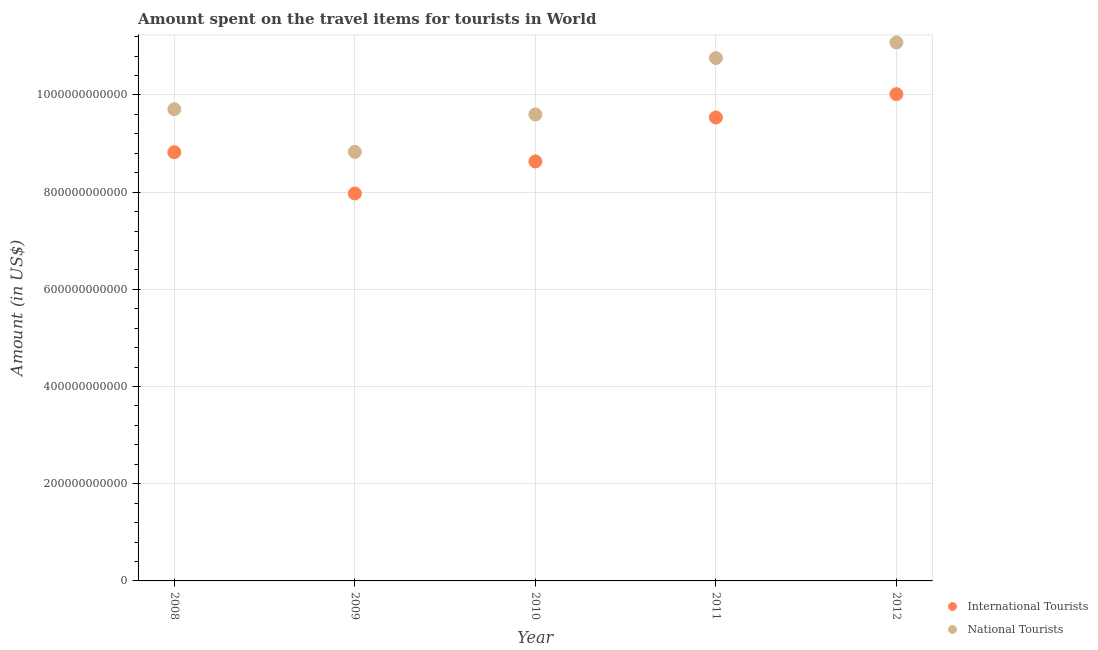How many different coloured dotlines are there?
Your answer should be very brief. 2. What is the amount spent on travel items of national tourists in 2012?
Make the answer very short. 1.11e+12. Across all years, what is the maximum amount spent on travel items of international tourists?
Provide a succinct answer. 1.00e+12. Across all years, what is the minimum amount spent on travel items of international tourists?
Provide a succinct answer. 7.97e+11. What is the total amount spent on travel items of international tourists in the graph?
Ensure brevity in your answer.  4.50e+12. What is the difference between the amount spent on travel items of international tourists in 2008 and that in 2010?
Your response must be concise. 1.91e+1. What is the difference between the amount spent on travel items of national tourists in 2010 and the amount spent on travel items of international tourists in 2012?
Provide a succinct answer. -4.18e+1. What is the average amount spent on travel items of national tourists per year?
Offer a terse response. 9.99e+11. In the year 2011, what is the difference between the amount spent on travel items of national tourists and amount spent on travel items of international tourists?
Offer a very short reply. 1.22e+11. In how many years, is the amount spent on travel items of national tourists greater than 1000000000000 US$?
Provide a succinct answer. 2. What is the ratio of the amount spent on travel items of national tourists in 2009 to that in 2011?
Give a very brief answer. 0.82. Is the amount spent on travel items of national tourists in 2011 less than that in 2012?
Offer a terse response. Yes. Is the difference between the amount spent on travel items of international tourists in 2008 and 2012 greater than the difference between the amount spent on travel items of national tourists in 2008 and 2012?
Your answer should be compact. Yes. What is the difference between the highest and the second highest amount spent on travel items of international tourists?
Your answer should be very brief. 4.80e+1. What is the difference between the highest and the lowest amount spent on travel items of national tourists?
Offer a very short reply. 2.25e+11. In how many years, is the amount spent on travel items of international tourists greater than the average amount spent on travel items of international tourists taken over all years?
Your response must be concise. 2. Is the amount spent on travel items of international tourists strictly greater than the amount spent on travel items of national tourists over the years?
Give a very brief answer. No. How many years are there in the graph?
Keep it short and to the point. 5. What is the difference between two consecutive major ticks on the Y-axis?
Offer a terse response. 2.00e+11. Does the graph contain grids?
Keep it short and to the point. Yes. Where does the legend appear in the graph?
Ensure brevity in your answer.  Bottom right. How are the legend labels stacked?
Your response must be concise. Vertical. What is the title of the graph?
Keep it short and to the point. Amount spent on the travel items for tourists in World. What is the label or title of the X-axis?
Make the answer very short. Year. What is the Amount (in US$) of International Tourists in 2008?
Offer a terse response. 8.82e+11. What is the Amount (in US$) of National Tourists in 2008?
Keep it short and to the point. 9.71e+11. What is the Amount (in US$) of International Tourists in 2009?
Provide a succinct answer. 7.97e+11. What is the Amount (in US$) in National Tourists in 2009?
Ensure brevity in your answer.  8.83e+11. What is the Amount (in US$) of International Tourists in 2010?
Your answer should be very brief. 8.63e+11. What is the Amount (in US$) in National Tourists in 2010?
Your answer should be compact. 9.60e+11. What is the Amount (in US$) of International Tourists in 2011?
Your answer should be compact. 9.54e+11. What is the Amount (in US$) in National Tourists in 2011?
Make the answer very short. 1.08e+12. What is the Amount (in US$) in International Tourists in 2012?
Your answer should be compact. 1.00e+12. What is the Amount (in US$) in National Tourists in 2012?
Offer a very short reply. 1.11e+12. Across all years, what is the maximum Amount (in US$) of International Tourists?
Ensure brevity in your answer.  1.00e+12. Across all years, what is the maximum Amount (in US$) in National Tourists?
Your response must be concise. 1.11e+12. Across all years, what is the minimum Amount (in US$) of International Tourists?
Keep it short and to the point. 7.97e+11. Across all years, what is the minimum Amount (in US$) in National Tourists?
Provide a succinct answer. 8.83e+11. What is the total Amount (in US$) of International Tourists in the graph?
Offer a very short reply. 4.50e+12. What is the total Amount (in US$) of National Tourists in the graph?
Ensure brevity in your answer.  5.00e+12. What is the difference between the Amount (in US$) in International Tourists in 2008 and that in 2009?
Ensure brevity in your answer.  8.50e+1. What is the difference between the Amount (in US$) of National Tourists in 2008 and that in 2009?
Make the answer very short. 8.78e+1. What is the difference between the Amount (in US$) of International Tourists in 2008 and that in 2010?
Make the answer very short. 1.91e+1. What is the difference between the Amount (in US$) in National Tourists in 2008 and that in 2010?
Keep it short and to the point. 1.07e+1. What is the difference between the Amount (in US$) of International Tourists in 2008 and that in 2011?
Your response must be concise. -7.15e+1. What is the difference between the Amount (in US$) of National Tourists in 2008 and that in 2011?
Keep it short and to the point. -1.05e+11. What is the difference between the Amount (in US$) of International Tourists in 2008 and that in 2012?
Your answer should be very brief. -1.19e+11. What is the difference between the Amount (in US$) in National Tourists in 2008 and that in 2012?
Offer a terse response. -1.37e+11. What is the difference between the Amount (in US$) in International Tourists in 2009 and that in 2010?
Ensure brevity in your answer.  -6.59e+1. What is the difference between the Amount (in US$) of National Tourists in 2009 and that in 2010?
Your answer should be compact. -7.70e+1. What is the difference between the Amount (in US$) of International Tourists in 2009 and that in 2011?
Your answer should be very brief. -1.56e+11. What is the difference between the Amount (in US$) in National Tourists in 2009 and that in 2011?
Offer a very short reply. -1.93e+11. What is the difference between the Amount (in US$) of International Tourists in 2009 and that in 2012?
Keep it short and to the point. -2.04e+11. What is the difference between the Amount (in US$) of National Tourists in 2009 and that in 2012?
Keep it short and to the point. -2.25e+11. What is the difference between the Amount (in US$) of International Tourists in 2010 and that in 2011?
Your answer should be very brief. -9.05e+1. What is the difference between the Amount (in US$) in National Tourists in 2010 and that in 2011?
Make the answer very short. -1.16e+11. What is the difference between the Amount (in US$) in International Tourists in 2010 and that in 2012?
Keep it short and to the point. -1.39e+11. What is the difference between the Amount (in US$) of National Tourists in 2010 and that in 2012?
Offer a very short reply. -1.48e+11. What is the difference between the Amount (in US$) of International Tourists in 2011 and that in 2012?
Keep it short and to the point. -4.80e+1. What is the difference between the Amount (in US$) in National Tourists in 2011 and that in 2012?
Give a very brief answer. -3.22e+1. What is the difference between the Amount (in US$) in International Tourists in 2008 and the Amount (in US$) in National Tourists in 2009?
Make the answer very short. -6.43e+08. What is the difference between the Amount (in US$) in International Tourists in 2008 and the Amount (in US$) in National Tourists in 2010?
Your response must be concise. -7.77e+1. What is the difference between the Amount (in US$) of International Tourists in 2008 and the Amount (in US$) of National Tourists in 2011?
Provide a succinct answer. -1.94e+11. What is the difference between the Amount (in US$) of International Tourists in 2008 and the Amount (in US$) of National Tourists in 2012?
Give a very brief answer. -2.26e+11. What is the difference between the Amount (in US$) in International Tourists in 2009 and the Amount (in US$) in National Tourists in 2010?
Give a very brief answer. -1.63e+11. What is the difference between the Amount (in US$) in International Tourists in 2009 and the Amount (in US$) in National Tourists in 2011?
Your answer should be very brief. -2.79e+11. What is the difference between the Amount (in US$) of International Tourists in 2009 and the Amount (in US$) of National Tourists in 2012?
Ensure brevity in your answer.  -3.11e+11. What is the difference between the Amount (in US$) in International Tourists in 2010 and the Amount (in US$) in National Tourists in 2011?
Provide a succinct answer. -2.13e+11. What is the difference between the Amount (in US$) in International Tourists in 2010 and the Amount (in US$) in National Tourists in 2012?
Provide a short and direct response. -2.45e+11. What is the difference between the Amount (in US$) in International Tourists in 2011 and the Amount (in US$) in National Tourists in 2012?
Provide a short and direct response. -1.54e+11. What is the average Amount (in US$) of International Tourists per year?
Ensure brevity in your answer.  9.00e+11. What is the average Amount (in US$) in National Tourists per year?
Offer a very short reply. 9.99e+11. In the year 2008, what is the difference between the Amount (in US$) in International Tourists and Amount (in US$) in National Tourists?
Your answer should be compact. -8.84e+1. In the year 2009, what is the difference between the Amount (in US$) in International Tourists and Amount (in US$) in National Tourists?
Your answer should be very brief. -8.56e+1. In the year 2010, what is the difference between the Amount (in US$) of International Tourists and Amount (in US$) of National Tourists?
Make the answer very short. -9.68e+1. In the year 2011, what is the difference between the Amount (in US$) in International Tourists and Amount (in US$) in National Tourists?
Your answer should be compact. -1.22e+11. In the year 2012, what is the difference between the Amount (in US$) of International Tourists and Amount (in US$) of National Tourists?
Your answer should be very brief. -1.06e+11. What is the ratio of the Amount (in US$) of International Tourists in 2008 to that in 2009?
Offer a terse response. 1.11. What is the ratio of the Amount (in US$) of National Tourists in 2008 to that in 2009?
Keep it short and to the point. 1.1. What is the ratio of the Amount (in US$) of International Tourists in 2008 to that in 2010?
Offer a very short reply. 1.02. What is the ratio of the Amount (in US$) in National Tourists in 2008 to that in 2010?
Provide a short and direct response. 1.01. What is the ratio of the Amount (in US$) of International Tourists in 2008 to that in 2011?
Your answer should be compact. 0.93. What is the ratio of the Amount (in US$) of National Tourists in 2008 to that in 2011?
Give a very brief answer. 0.9. What is the ratio of the Amount (in US$) in International Tourists in 2008 to that in 2012?
Ensure brevity in your answer.  0.88. What is the ratio of the Amount (in US$) of National Tourists in 2008 to that in 2012?
Keep it short and to the point. 0.88. What is the ratio of the Amount (in US$) in International Tourists in 2009 to that in 2010?
Provide a short and direct response. 0.92. What is the ratio of the Amount (in US$) of National Tourists in 2009 to that in 2010?
Your answer should be compact. 0.92. What is the ratio of the Amount (in US$) of International Tourists in 2009 to that in 2011?
Offer a very short reply. 0.84. What is the ratio of the Amount (in US$) of National Tourists in 2009 to that in 2011?
Ensure brevity in your answer.  0.82. What is the ratio of the Amount (in US$) in International Tourists in 2009 to that in 2012?
Make the answer very short. 0.8. What is the ratio of the Amount (in US$) in National Tourists in 2009 to that in 2012?
Keep it short and to the point. 0.8. What is the ratio of the Amount (in US$) in International Tourists in 2010 to that in 2011?
Offer a terse response. 0.91. What is the ratio of the Amount (in US$) of National Tourists in 2010 to that in 2011?
Offer a very short reply. 0.89. What is the ratio of the Amount (in US$) in International Tourists in 2010 to that in 2012?
Make the answer very short. 0.86. What is the ratio of the Amount (in US$) of National Tourists in 2010 to that in 2012?
Keep it short and to the point. 0.87. What is the ratio of the Amount (in US$) of International Tourists in 2011 to that in 2012?
Provide a succinct answer. 0.95. What is the ratio of the Amount (in US$) of National Tourists in 2011 to that in 2012?
Your answer should be very brief. 0.97. What is the difference between the highest and the second highest Amount (in US$) of International Tourists?
Make the answer very short. 4.80e+1. What is the difference between the highest and the second highest Amount (in US$) of National Tourists?
Provide a short and direct response. 3.22e+1. What is the difference between the highest and the lowest Amount (in US$) of International Tourists?
Provide a succinct answer. 2.04e+11. What is the difference between the highest and the lowest Amount (in US$) in National Tourists?
Give a very brief answer. 2.25e+11. 